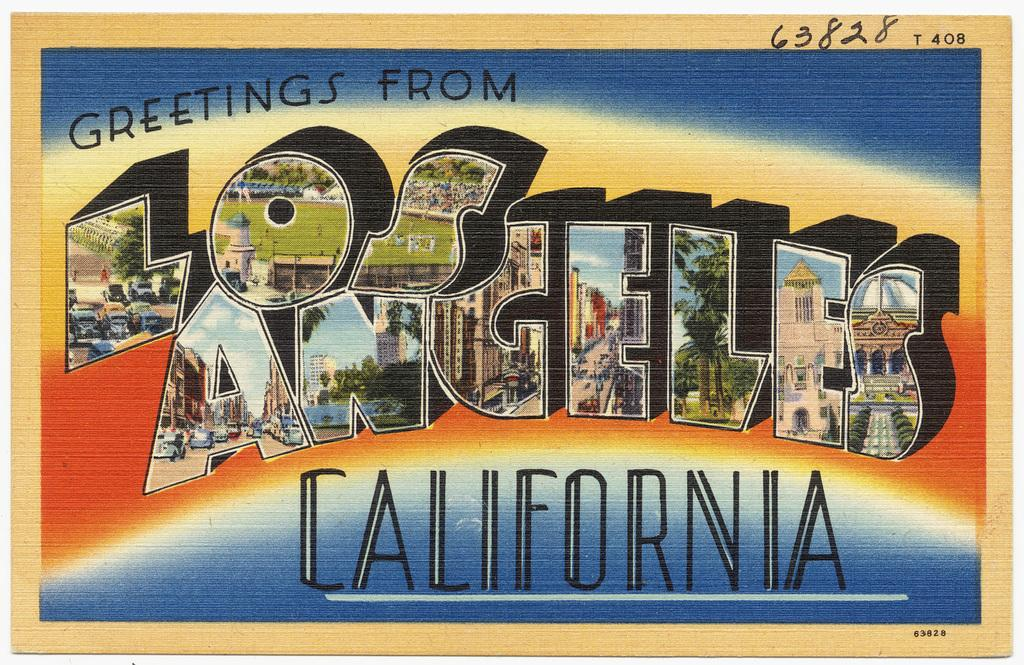<image>
Present a compact description of the photo's key features. a postcard that says California on the front 